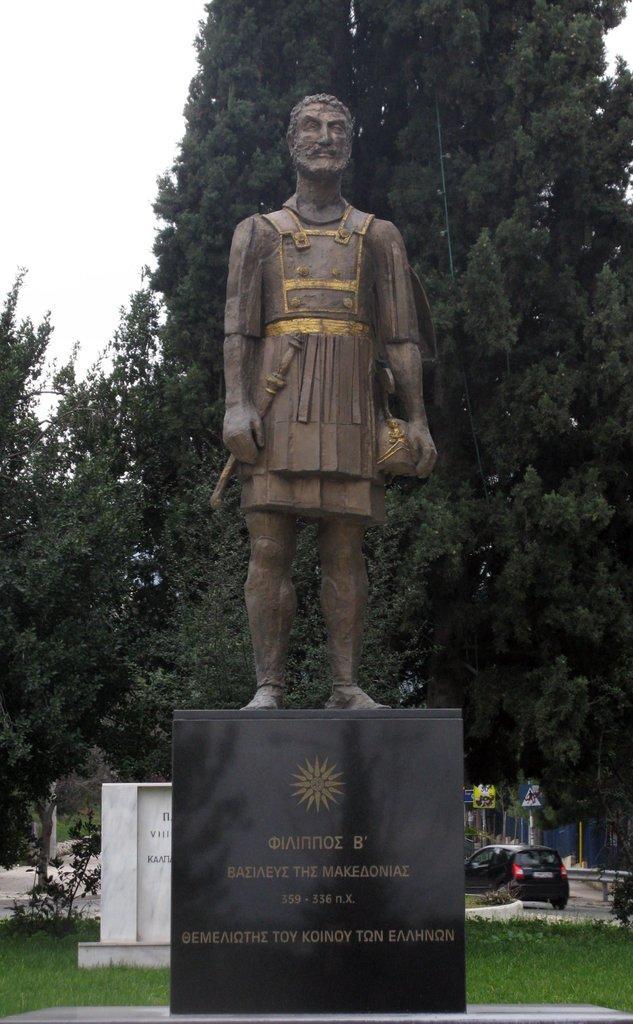Please provide a concise description of this image. In this picture there is a statue of a person in the foreground and the is text on the wall. At the back there are trees and there is a vehicle and railing and there are boards on poles. At the top there is sky. At the bottom there is grass. 